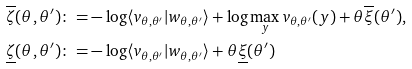Convert formula to latex. <formula><loc_0><loc_0><loc_500><loc_500>\overline { \zeta } ( \theta , \theta ^ { \prime } ) \colon = & - \log \langle v _ { \theta , \theta ^ { \prime } } | w _ { \theta , \theta ^ { \prime } } \rangle + \log \max _ { y } v _ { \theta , \theta ^ { \prime } } ( y ) + \theta \overline { \xi } ( \theta ^ { \prime } ) , \\ \underline { \zeta } ( \theta , \theta ^ { \prime } ) \colon = & - \log \langle v _ { \theta , \theta ^ { \prime } } | w _ { \theta , \theta ^ { \prime } } \rangle + \theta \underline { \xi } ( \theta ^ { \prime } )</formula> 